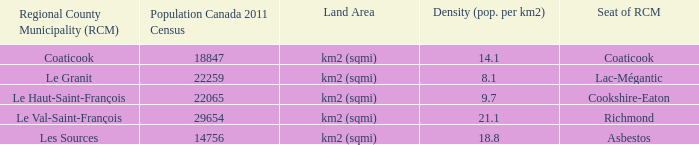Where is the rcm situated in the county having a density of Cookshire-Eaton. 